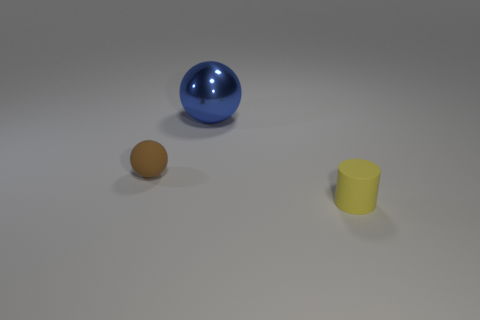Subtract all blue balls. Subtract all brown cylinders. How many balls are left? 1 Add 2 tiny green spheres. How many objects exist? 5 Subtract all spheres. How many objects are left? 1 Add 2 yellow rubber objects. How many yellow rubber objects exist? 3 Subtract 0 gray balls. How many objects are left? 3 Subtract all red matte objects. Subtract all big blue shiny objects. How many objects are left? 2 Add 3 blue metallic balls. How many blue metallic balls are left? 4 